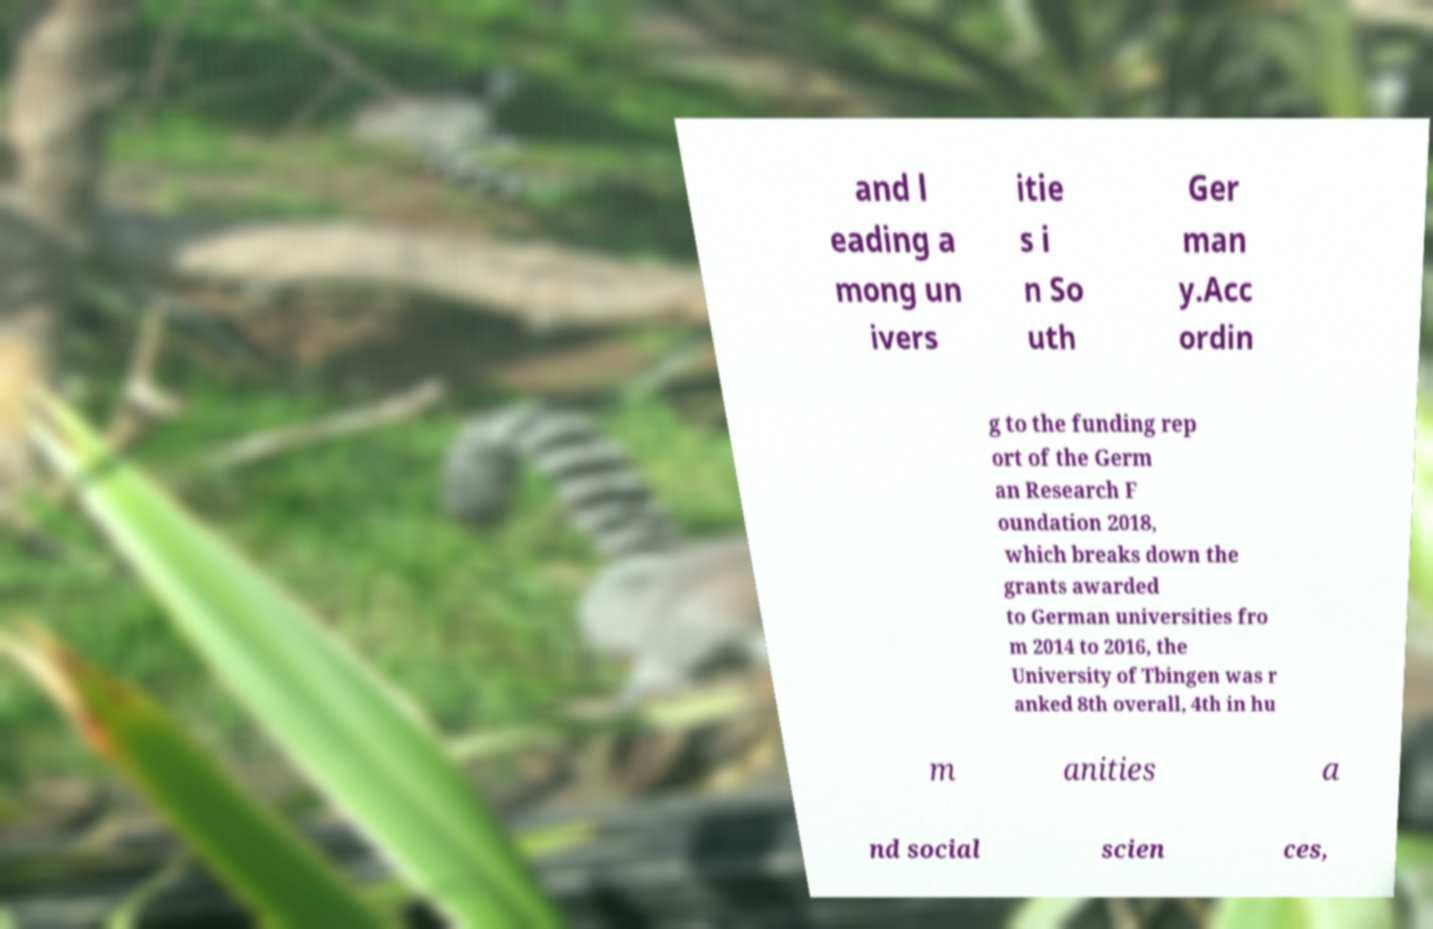I need the written content from this picture converted into text. Can you do that? and l eading a mong un ivers itie s i n So uth Ger man y.Acc ordin g to the funding rep ort of the Germ an Research F oundation 2018, which breaks down the grants awarded to German universities fro m 2014 to 2016, the University of Tbingen was r anked 8th overall, 4th in hu m anities a nd social scien ces, 